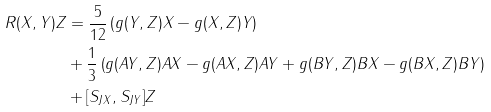Convert formula to latex. <formula><loc_0><loc_0><loc_500><loc_500>R ( X , Y ) Z & = \frac { 5 } { 1 2 } \left ( g ( Y , Z ) X - g ( X , Z ) Y \right ) \\ & + \frac { 1 } { 3 } \left ( g ( A Y , Z ) A X - g ( A X , Z ) A Y + g ( B Y , Z ) B X - g ( B X , Z ) B Y \right ) \\ & + [ S _ { J X } , S _ { J Y } ] Z</formula> 